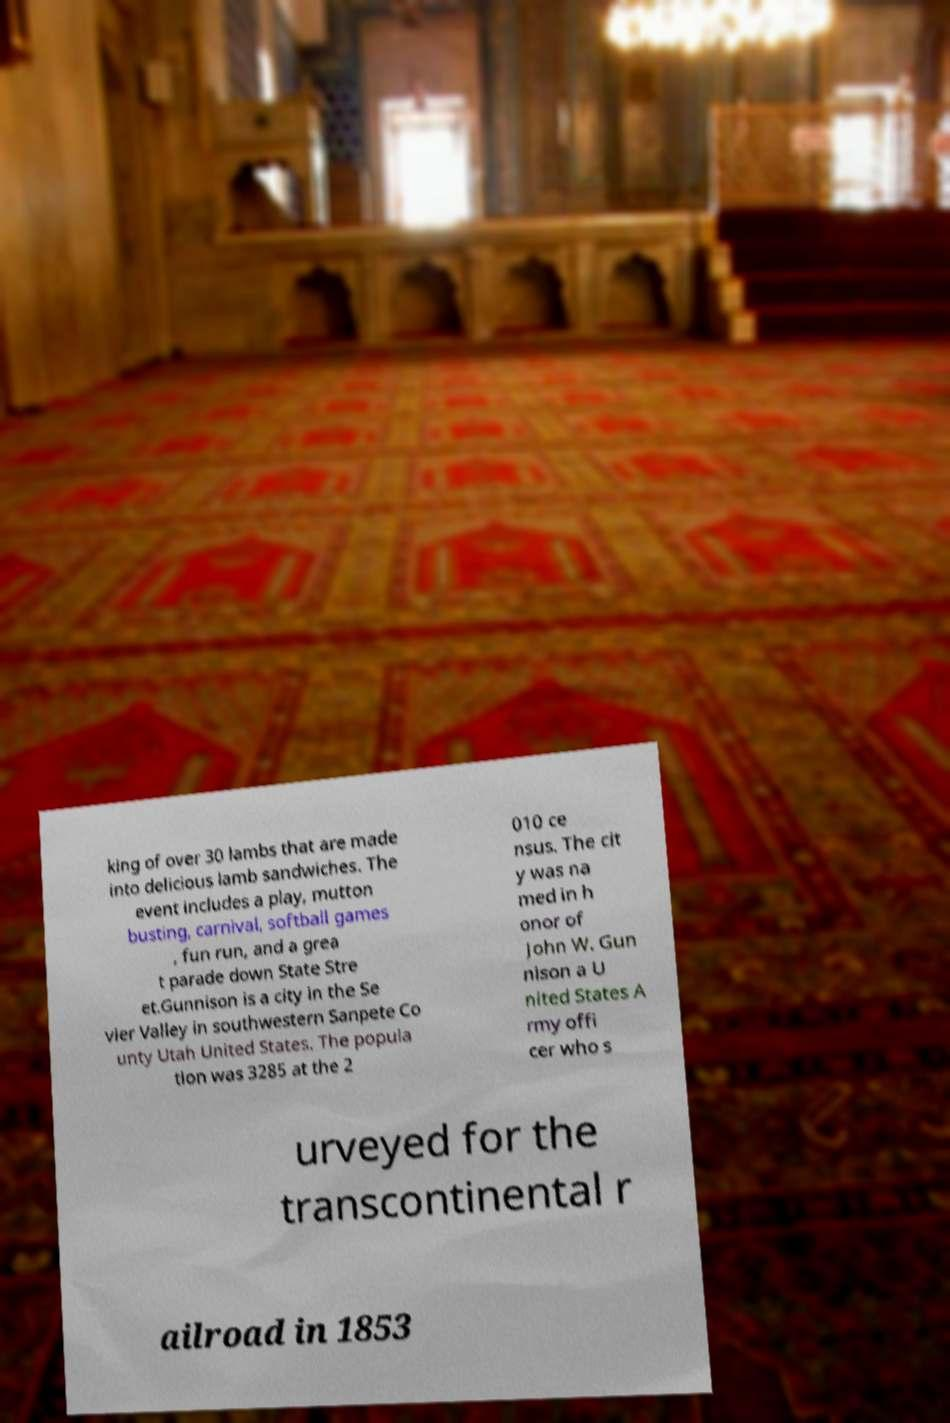There's text embedded in this image that I need extracted. Can you transcribe it verbatim? king of over 30 lambs that are made into delicious lamb sandwiches. The event includes a play, mutton busting, carnival, softball games , fun run, and a grea t parade down State Stre et.Gunnison is a city in the Se vier Valley in southwestern Sanpete Co unty Utah United States. The popula tion was 3285 at the 2 010 ce nsus. The cit y was na med in h onor of John W. Gun nison a U nited States A rmy offi cer who s urveyed for the transcontinental r ailroad in 1853 